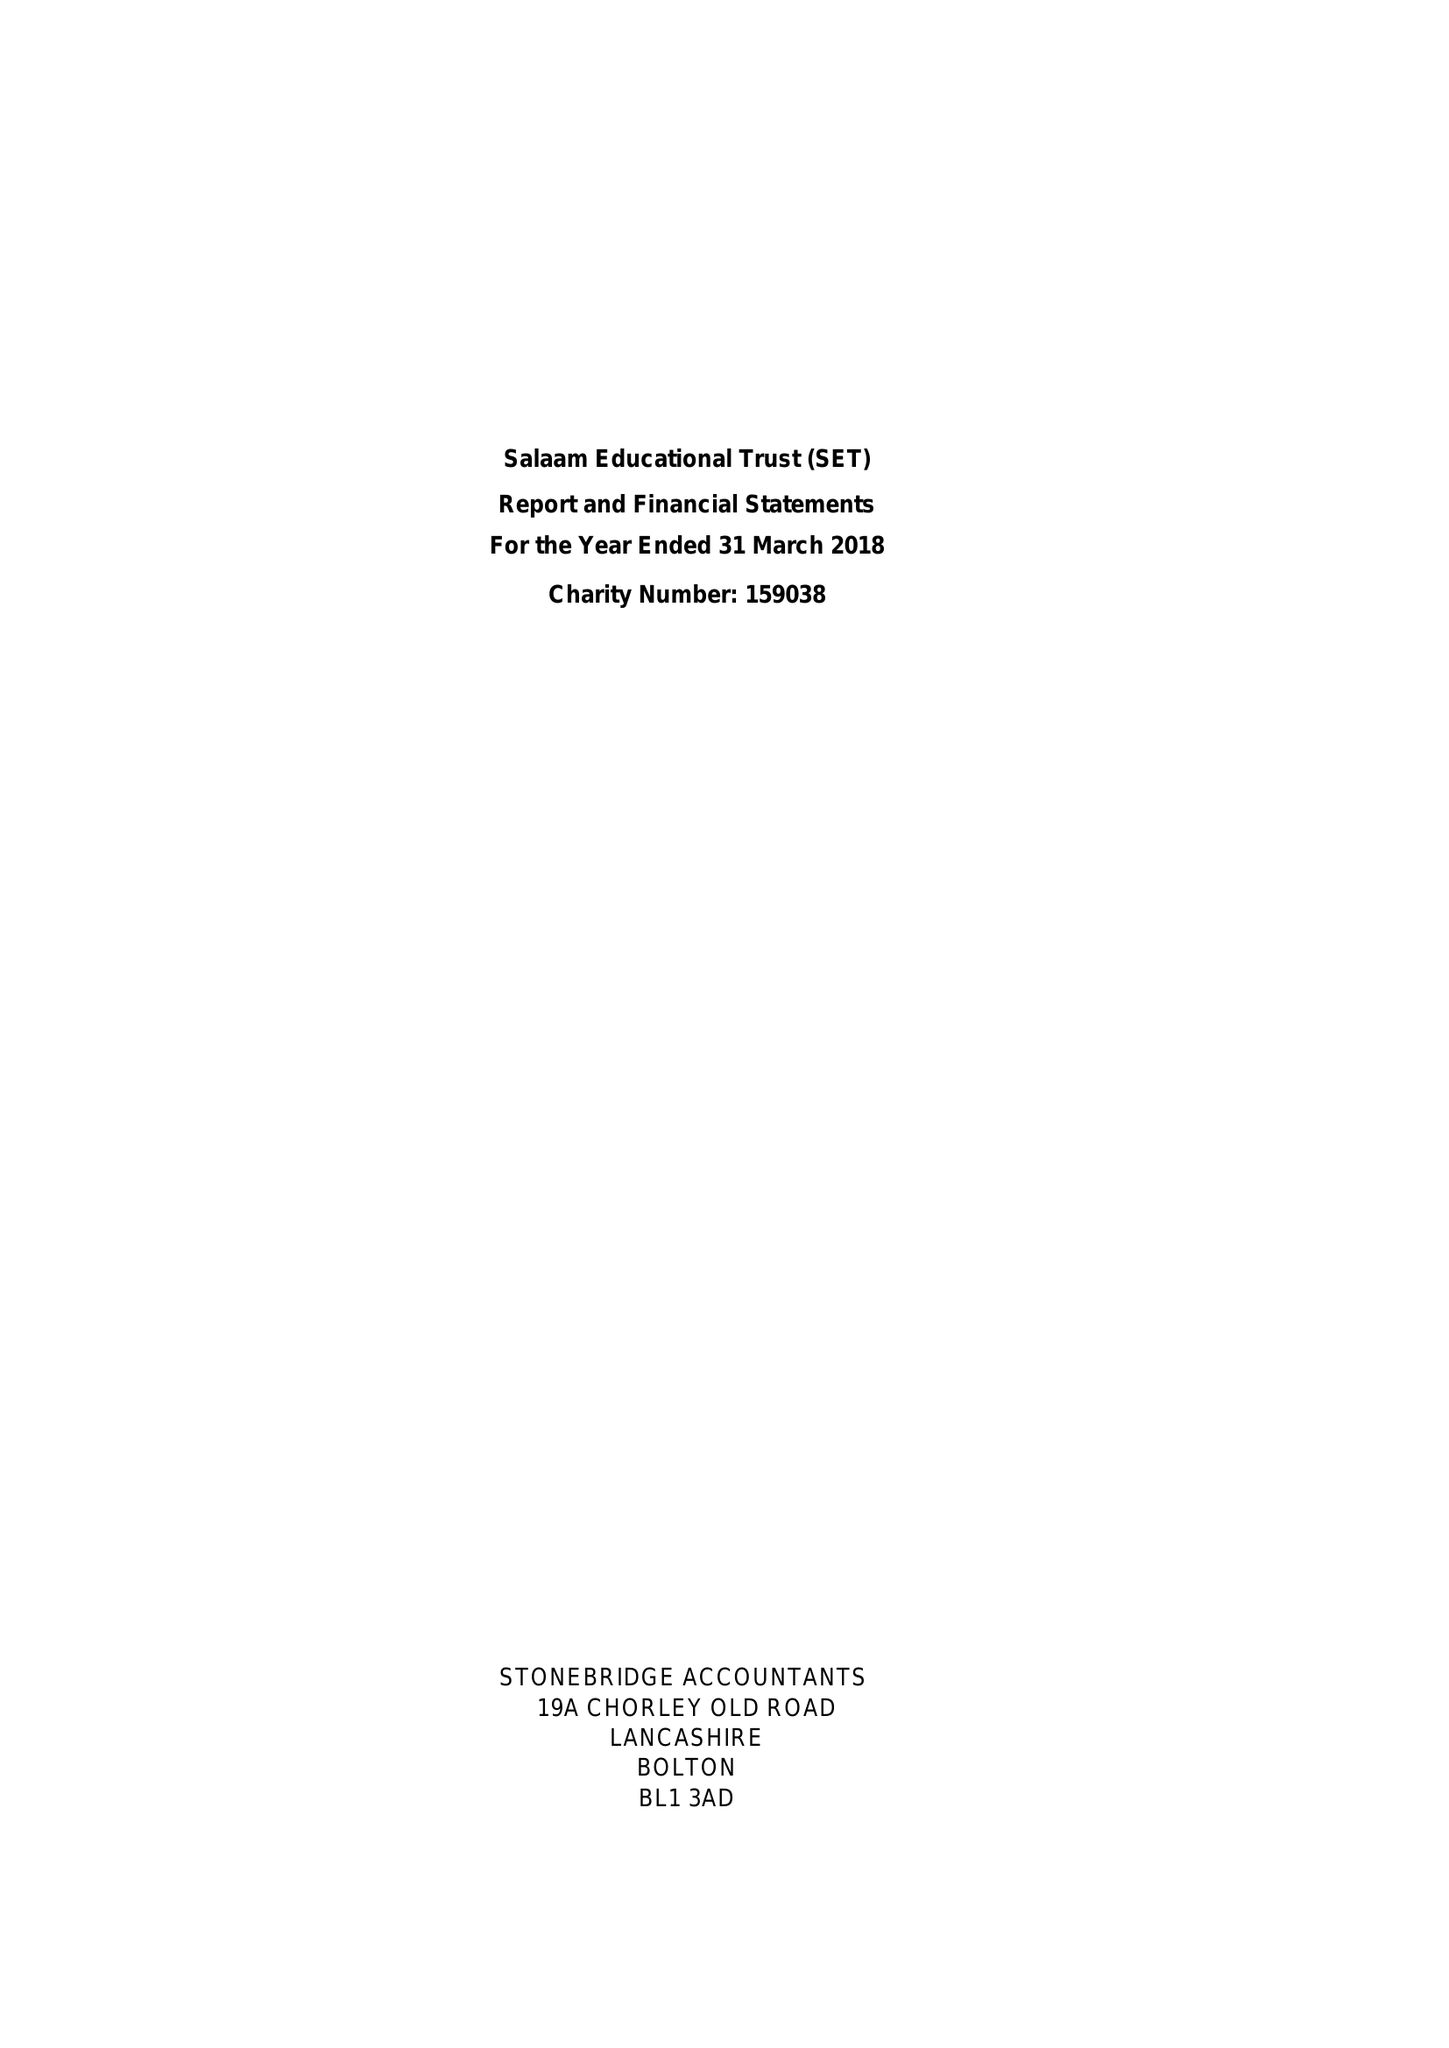What is the value for the charity_name?
Answer the question using a single word or phrase. Salaam Educational Trust 